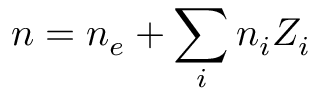<formula> <loc_0><loc_0><loc_500><loc_500>n = n _ { e } + \sum _ { i } n _ { i } Z _ { i }</formula> 